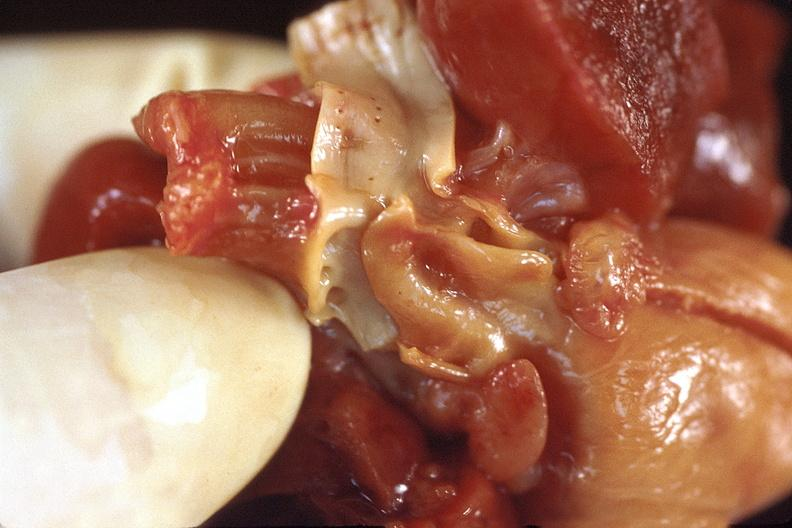where is this?
Answer the question using a single word or phrase. Heart 